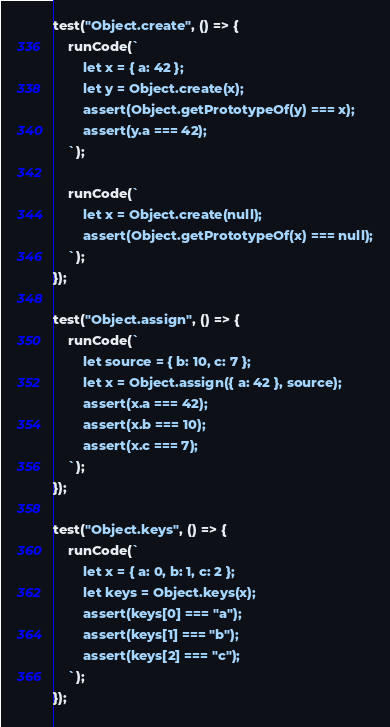Convert code to text. <code><loc_0><loc_0><loc_500><loc_500><_JavaScript_>test("Object.create", () => {
    runCode(`
        let x = { a: 42 };
        let y = Object.create(x);
        assert(Object.getPrototypeOf(y) === x);
        assert(y.a === 42);
    `);

    runCode(`
        let x = Object.create(null);
        assert(Object.getPrototypeOf(x) === null);
    `);
});

test("Object.assign", () => {
    runCode(`
        let source = { b: 10, c: 7 };
        let x = Object.assign({ a: 42 }, source);
        assert(x.a === 42);
        assert(x.b === 10);
        assert(x.c === 7);
    `);
});

test("Object.keys", () => {
    runCode(`
        let x = { a: 0, b: 1, c: 2 };
        let keys = Object.keys(x);
        assert(keys[0] === "a");
        assert(keys[1] === "b");
        assert(keys[2] === "c");
    `);
});
</code> 